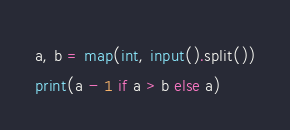Convert code to text. <code><loc_0><loc_0><loc_500><loc_500><_Python_>a, b = map(int, input().split())
print(a - 1 if a > b else a)</code> 